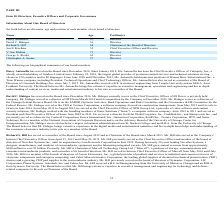From Xperi Corporation's financial document, Who are the members of the board of directors? The document contains multiple relevant values: Darcy Antonellis, David C. Habiger, Richard S. Hill, Jon E. Kirchner, V. Sue Molina, George A. Riedel, Christopher A. Seams. From the document: "George A. Riedel 62 Director Richard S. Hill 68 Chairman of the Board of Directors Jon E. Kirchner 52 Chief Executive Officer and Director David C. Ha..." Also, Who is the Chairman of the Board? According to the financial document, Richard S. Hill. The relevant text states: "Richard S. Hill 68 Chairman of the Board of Directors..." Also, can you calculate: What is the average age of the board members? To answer this question, I need to perform calculations using the financial data. The calculation is: (57+51+68+52+71+62+57)/7 , which equals 59.71. This is based on the information: "George A. Riedel 62 Director Darcy Antonellis 57 Director David C. Habiger 51 Director Jon E. Kirchner 52 Chief Executive Officer and Director V. Sue Molina 71 Director Richard S. Hill 68 Chairman of ..." The key data points involved are: 51, 52, 57. Additionally, Who is the oldest among all board members? According to the financial document, V. Sue Molina. The relevant text states: "V. Sue Molina 71 Director..." Also, can you calculate: What is the proportion of years that David C. Habiger worked in Sonic Solutions throughout his whole life? To answer this question, I need to perform calculations using the financial data. The calculation is: (2011-1992)/51 , which equals 0.37. This is based on the information: "David C. Habiger 51 Director ions (“Sonic”), a computer software company, from 1992 to 2011 and served as President and Chief Executive Officer of Sonic from 2005 to 2011. He serves a 5 until its sale..." The key data points involved are: 1992, 2011, 51. Also, Since when did Darcy Antonellis serve as a member of the Board of Directors? According to the financial document, December 2018. The relevant text states: "s. Darcy Antonellis has served on the Board since December 2018. Since January 2014, Ms. Antonellis has been the Chief Executive Officer of Vubiquity, Inc., a whol..." 